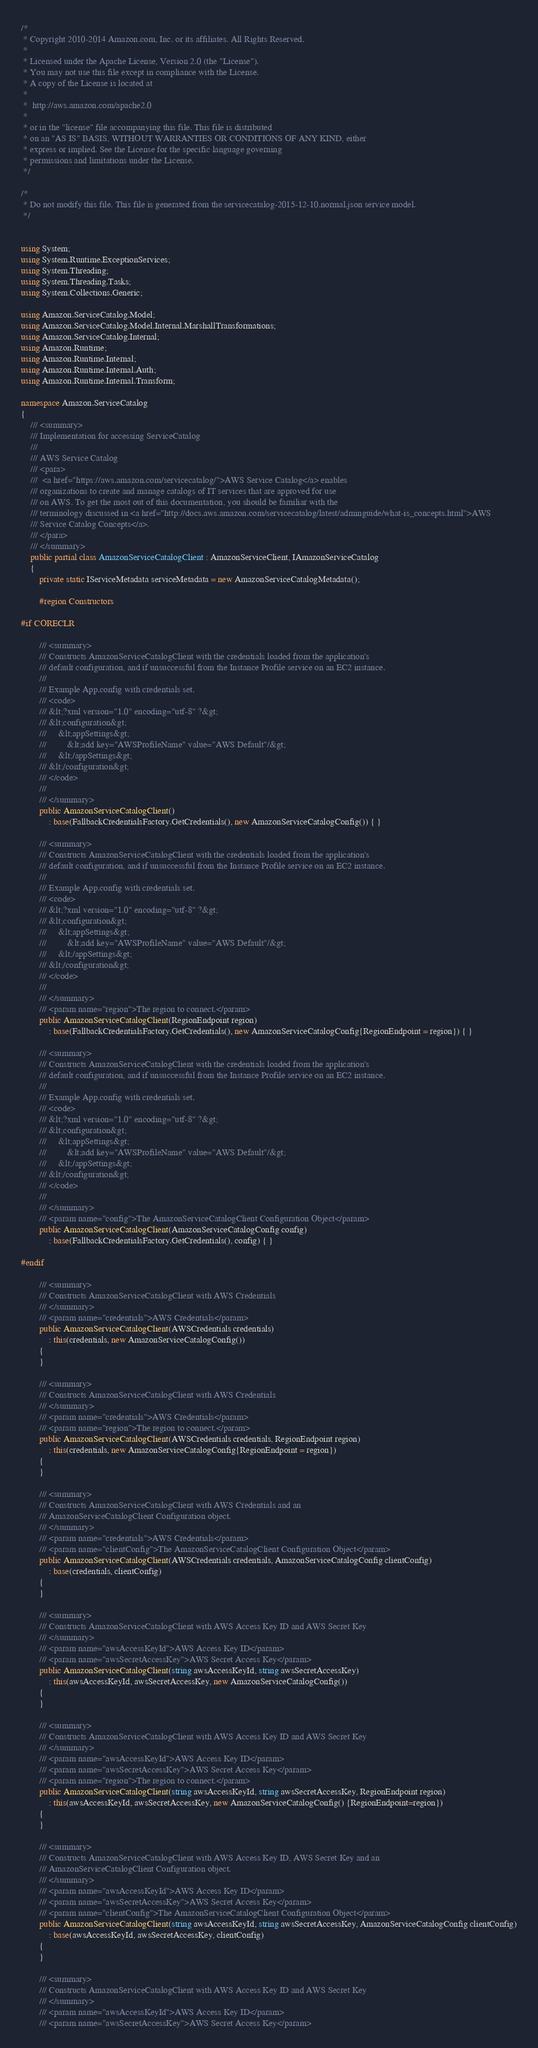<code> <loc_0><loc_0><loc_500><loc_500><_C#_>/*
 * Copyright 2010-2014 Amazon.com, Inc. or its affiliates. All Rights Reserved.
 * 
 * Licensed under the Apache License, Version 2.0 (the "License").
 * You may not use this file except in compliance with the License.
 * A copy of the License is located at
 * 
 *  http://aws.amazon.com/apache2.0
 * 
 * or in the "license" file accompanying this file. This file is distributed
 * on an "AS IS" BASIS, WITHOUT WARRANTIES OR CONDITIONS OF ANY KIND, either
 * express or implied. See the License for the specific language governing
 * permissions and limitations under the License.
 */

/*
 * Do not modify this file. This file is generated from the servicecatalog-2015-12-10.normal.json service model.
 */


using System;
using System.Runtime.ExceptionServices;
using System.Threading;
using System.Threading.Tasks;
using System.Collections.Generic;

using Amazon.ServiceCatalog.Model;
using Amazon.ServiceCatalog.Model.Internal.MarshallTransformations;
using Amazon.ServiceCatalog.Internal;
using Amazon.Runtime;
using Amazon.Runtime.Internal;
using Amazon.Runtime.Internal.Auth;
using Amazon.Runtime.Internal.Transform;

namespace Amazon.ServiceCatalog
{
    /// <summary>
    /// Implementation for accessing ServiceCatalog
    ///
    /// AWS Service Catalog 
    /// <para>
    ///  <a href="https://aws.amazon.com/servicecatalog/">AWS Service Catalog</a> enables
    /// organizations to create and manage catalogs of IT services that are approved for use
    /// on AWS. To get the most out of this documentation, you should be familiar with the
    /// terminology discussed in <a href="http://docs.aws.amazon.com/servicecatalog/latest/adminguide/what-is_concepts.html">AWS
    /// Service Catalog Concepts</a>.
    /// </para>
    /// </summary>
    public partial class AmazonServiceCatalogClient : AmazonServiceClient, IAmazonServiceCatalog
    {
        private static IServiceMetadata serviceMetadata = new AmazonServiceCatalogMetadata();
        
        #region Constructors

#if CORECLR
    
        /// <summary>
        /// Constructs AmazonServiceCatalogClient with the credentials loaded from the application's
        /// default configuration, and if unsuccessful from the Instance Profile service on an EC2 instance.
        /// 
        /// Example App.config with credentials set. 
        /// <code>
        /// &lt;?xml version="1.0" encoding="utf-8" ?&gt;
        /// &lt;configuration&gt;
        ///     &lt;appSettings&gt;
        ///         &lt;add key="AWSProfileName" value="AWS Default"/&gt;
        ///     &lt;/appSettings&gt;
        /// &lt;/configuration&gt;
        /// </code>
        ///
        /// </summary>
        public AmazonServiceCatalogClient()
            : base(FallbackCredentialsFactory.GetCredentials(), new AmazonServiceCatalogConfig()) { }

        /// <summary>
        /// Constructs AmazonServiceCatalogClient with the credentials loaded from the application's
        /// default configuration, and if unsuccessful from the Instance Profile service on an EC2 instance.
        /// 
        /// Example App.config with credentials set. 
        /// <code>
        /// &lt;?xml version="1.0" encoding="utf-8" ?&gt;
        /// &lt;configuration&gt;
        ///     &lt;appSettings&gt;
        ///         &lt;add key="AWSProfileName" value="AWS Default"/&gt;
        ///     &lt;/appSettings&gt;
        /// &lt;/configuration&gt;
        /// </code>
        ///
        /// </summary>
        /// <param name="region">The region to connect.</param>
        public AmazonServiceCatalogClient(RegionEndpoint region)
            : base(FallbackCredentialsFactory.GetCredentials(), new AmazonServiceCatalogConfig{RegionEndpoint = region}) { }

        /// <summary>
        /// Constructs AmazonServiceCatalogClient with the credentials loaded from the application's
        /// default configuration, and if unsuccessful from the Instance Profile service on an EC2 instance.
        /// 
        /// Example App.config with credentials set. 
        /// <code>
        /// &lt;?xml version="1.0" encoding="utf-8" ?&gt;
        /// &lt;configuration&gt;
        ///     &lt;appSettings&gt;
        ///         &lt;add key="AWSProfileName" value="AWS Default"/&gt;
        ///     &lt;/appSettings&gt;
        /// &lt;/configuration&gt;
        /// </code>
        ///
        /// </summary>
        /// <param name="config">The AmazonServiceCatalogClient Configuration Object</param>
        public AmazonServiceCatalogClient(AmazonServiceCatalogConfig config)
            : base(FallbackCredentialsFactory.GetCredentials(), config) { }

#endif

        /// <summary>
        /// Constructs AmazonServiceCatalogClient with AWS Credentials
        /// </summary>
        /// <param name="credentials">AWS Credentials</param>
        public AmazonServiceCatalogClient(AWSCredentials credentials)
            : this(credentials, new AmazonServiceCatalogConfig())
        {
        }

        /// <summary>
        /// Constructs AmazonServiceCatalogClient with AWS Credentials
        /// </summary>
        /// <param name="credentials">AWS Credentials</param>
        /// <param name="region">The region to connect.</param>
        public AmazonServiceCatalogClient(AWSCredentials credentials, RegionEndpoint region)
            : this(credentials, new AmazonServiceCatalogConfig{RegionEndpoint = region})
        {
        }

        /// <summary>
        /// Constructs AmazonServiceCatalogClient with AWS Credentials and an
        /// AmazonServiceCatalogClient Configuration object.
        /// </summary>
        /// <param name="credentials">AWS Credentials</param>
        /// <param name="clientConfig">The AmazonServiceCatalogClient Configuration Object</param>
        public AmazonServiceCatalogClient(AWSCredentials credentials, AmazonServiceCatalogConfig clientConfig)
            : base(credentials, clientConfig)
        {
        }

        /// <summary>
        /// Constructs AmazonServiceCatalogClient with AWS Access Key ID and AWS Secret Key
        /// </summary>
        /// <param name="awsAccessKeyId">AWS Access Key ID</param>
        /// <param name="awsSecretAccessKey">AWS Secret Access Key</param>
        public AmazonServiceCatalogClient(string awsAccessKeyId, string awsSecretAccessKey)
            : this(awsAccessKeyId, awsSecretAccessKey, new AmazonServiceCatalogConfig())
        {
        }

        /// <summary>
        /// Constructs AmazonServiceCatalogClient with AWS Access Key ID and AWS Secret Key
        /// </summary>
        /// <param name="awsAccessKeyId">AWS Access Key ID</param>
        /// <param name="awsSecretAccessKey">AWS Secret Access Key</param>
        /// <param name="region">The region to connect.</param>
        public AmazonServiceCatalogClient(string awsAccessKeyId, string awsSecretAccessKey, RegionEndpoint region)
            : this(awsAccessKeyId, awsSecretAccessKey, new AmazonServiceCatalogConfig() {RegionEndpoint=region})
        {
        }

        /// <summary>
        /// Constructs AmazonServiceCatalogClient with AWS Access Key ID, AWS Secret Key and an
        /// AmazonServiceCatalogClient Configuration object. 
        /// </summary>
        /// <param name="awsAccessKeyId">AWS Access Key ID</param>
        /// <param name="awsSecretAccessKey">AWS Secret Access Key</param>
        /// <param name="clientConfig">The AmazonServiceCatalogClient Configuration Object</param>
        public AmazonServiceCatalogClient(string awsAccessKeyId, string awsSecretAccessKey, AmazonServiceCatalogConfig clientConfig)
            : base(awsAccessKeyId, awsSecretAccessKey, clientConfig)
        {
        }

        /// <summary>
        /// Constructs AmazonServiceCatalogClient with AWS Access Key ID and AWS Secret Key
        /// </summary>
        /// <param name="awsAccessKeyId">AWS Access Key ID</param>
        /// <param name="awsSecretAccessKey">AWS Secret Access Key</param></code> 